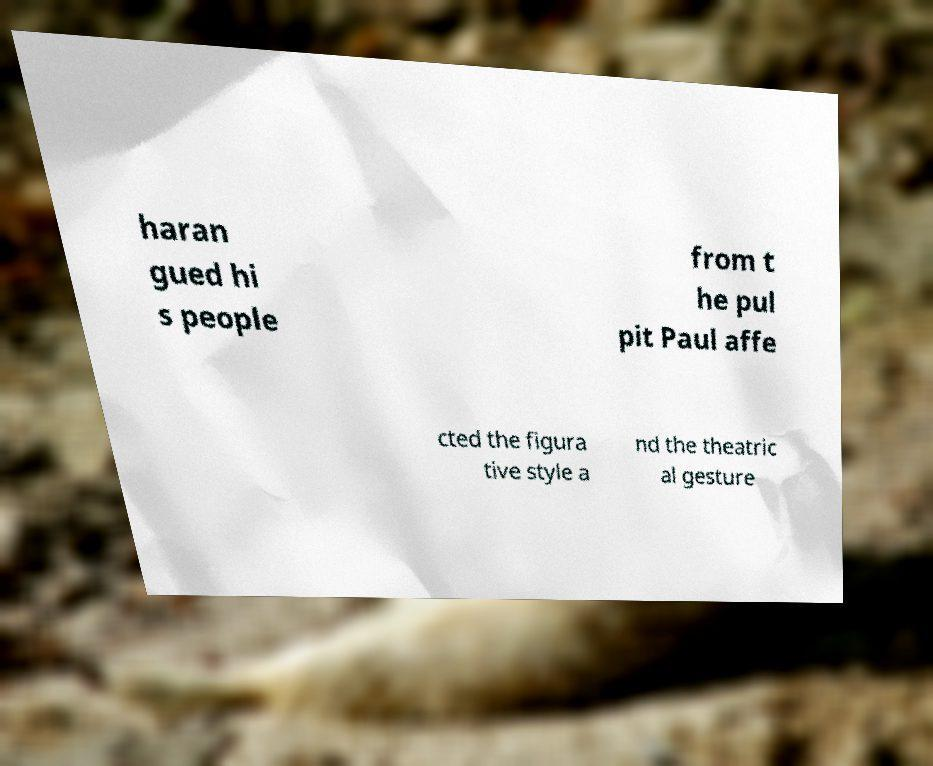Please read and relay the text visible in this image. What does it say? haran gued hi s people from t he pul pit Paul affe cted the figura tive style a nd the theatric al gesture 